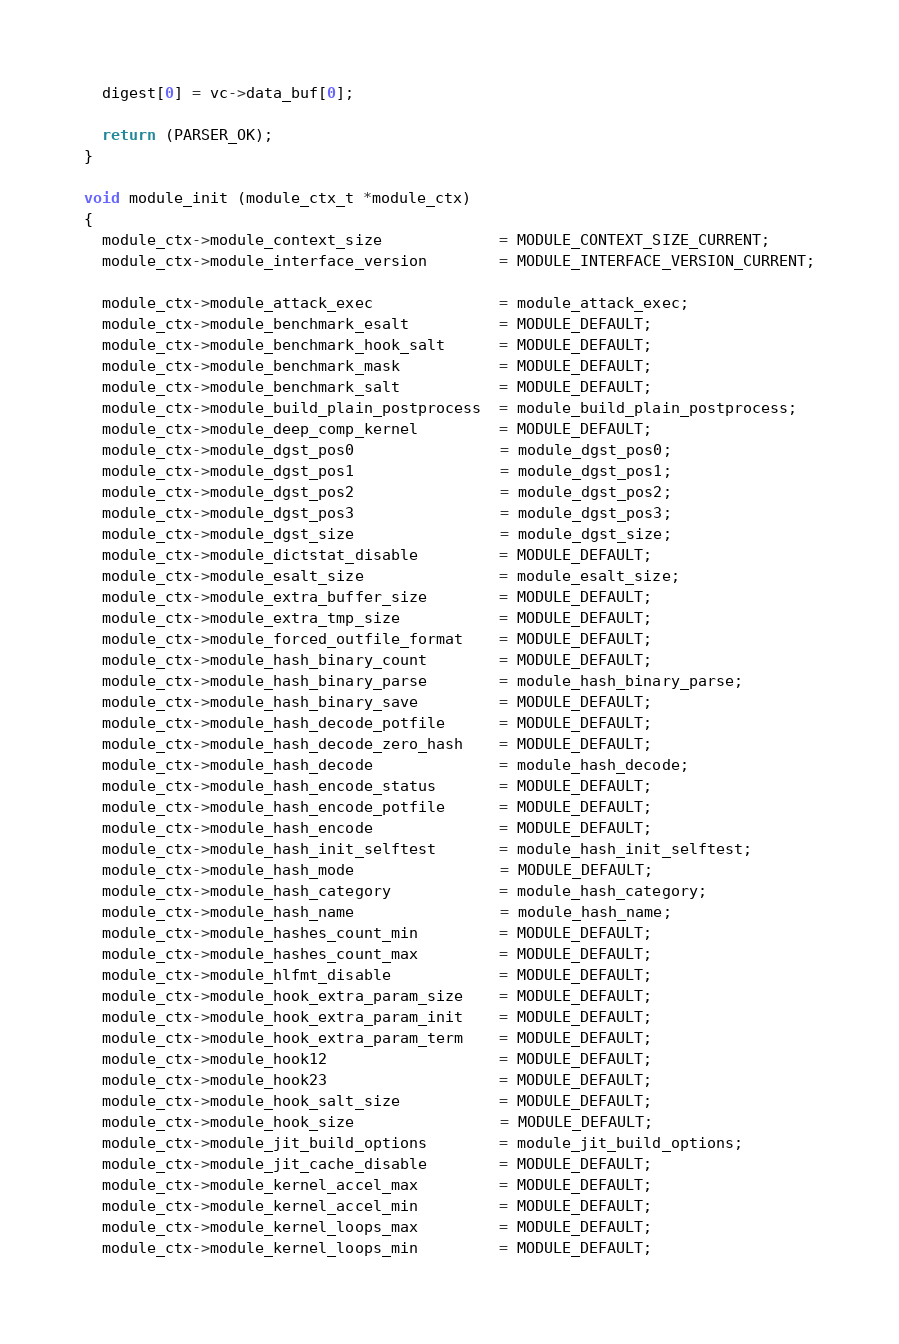<code> <loc_0><loc_0><loc_500><loc_500><_C_>
  digest[0] = vc->data_buf[0];

  return (PARSER_OK);
}

void module_init (module_ctx_t *module_ctx)
{
  module_ctx->module_context_size             = MODULE_CONTEXT_SIZE_CURRENT;
  module_ctx->module_interface_version        = MODULE_INTERFACE_VERSION_CURRENT;

  module_ctx->module_attack_exec              = module_attack_exec;
  module_ctx->module_benchmark_esalt          = MODULE_DEFAULT;
  module_ctx->module_benchmark_hook_salt      = MODULE_DEFAULT;
  module_ctx->module_benchmark_mask           = MODULE_DEFAULT;
  module_ctx->module_benchmark_salt           = MODULE_DEFAULT;
  module_ctx->module_build_plain_postprocess  = module_build_plain_postprocess;
  module_ctx->module_deep_comp_kernel         = MODULE_DEFAULT;
  module_ctx->module_dgst_pos0                = module_dgst_pos0;
  module_ctx->module_dgst_pos1                = module_dgst_pos1;
  module_ctx->module_dgst_pos2                = module_dgst_pos2;
  module_ctx->module_dgst_pos3                = module_dgst_pos3;
  module_ctx->module_dgst_size                = module_dgst_size;
  module_ctx->module_dictstat_disable         = MODULE_DEFAULT;
  module_ctx->module_esalt_size               = module_esalt_size;
  module_ctx->module_extra_buffer_size        = MODULE_DEFAULT;
  module_ctx->module_extra_tmp_size           = MODULE_DEFAULT;
  module_ctx->module_forced_outfile_format    = MODULE_DEFAULT;
  module_ctx->module_hash_binary_count        = MODULE_DEFAULT;
  module_ctx->module_hash_binary_parse        = module_hash_binary_parse;
  module_ctx->module_hash_binary_save         = MODULE_DEFAULT;
  module_ctx->module_hash_decode_potfile      = MODULE_DEFAULT;
  module_ctx->module_hash_decode_zero_hash    = MODULE_DEFAULT;
  module_ctx->module_hash_decode              = module_hash_decode;
  module_ctx->module_hash_encode_status       = MODULE_DEFAULT;
  module_ctx->module_hash_encode_potfile      = MODULE_DEFAULT;
  module_ctx->module_hash_encode              = MODULE_DEFAULT;
  module_ctx->module_hash_init_selftest       = module_hash_init_selftest;
  module_ctx->module_hash_mode                = MODULE_DEFAULT;
  module_ctx->module_hash_category            = module_hash_category;
  module_ctx->module_hash_name                = module_hash_name;
  module_ctx->module_hashes_count_min         = MODULE_DEFAULT;
  module_ctx->module_hashes_count_max         = MODULE_DEFAULT;
  module_ctx->module_hlfmt_disable            = MODULE_DEFAULT;
  module_ctx->module_hook_extra_param_size    = MODULE_DEFAULT;
  module_ctx->module_hook_extra_param_init    = MODULE_DEFAULT;
  module_ctx->module_hook_extra_param_term    = MODULE_DEFAULT;
  module_ctx->module_hook12                   = MODULE_DEFAULT;
  module_ctx->module_hook23                   = MODULE_DEFAULT;
  module_ctx->module_hook_salt_size           = MODULE_DEFAULT;
  module_ctx->module_hook_size                = MODULE_DEFAULT;
  module_ctx->module_jit_build_options        = module_jit_build_options;
  module_ctx->module_jit_cache_disable        = MODULE_DEFAULT;
  module_ctx->module_kernel_accel_max         = MODULE_DEFAULT;
  module_ctx->module_kernel_accel_min         = MODULE_DEFAULT;
  module_ctx->module_kernel_loops_max         = MODULE_DEFAULT;
  module_ctx->module_kernel_loops_min         = MODULE_DEFAULT;</code> 